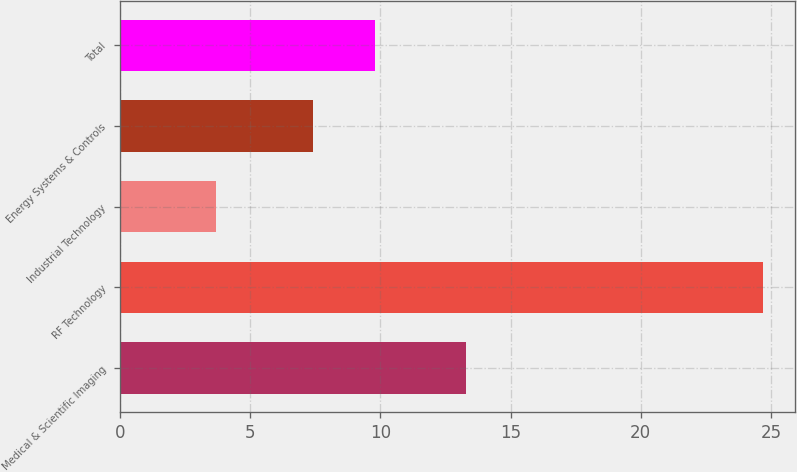Convert chart to OTSL. <chart><loc_0><loc_0><loc_500><loc_500><bar_chart><fcel>Medical & Scientific Imaging<fcel>RF Technology<fcel>Industrial Technology<fcel>Energy Systems & Controls<fcel>Total<nl><fcel>13.3<fcel>24.7<fcel>3.7<fcel>7.4<fcel>9.8<nl></chart> 